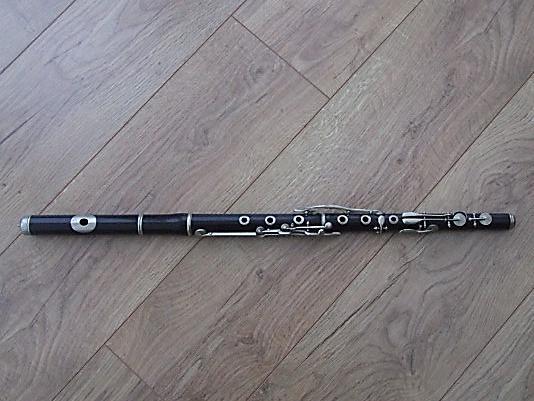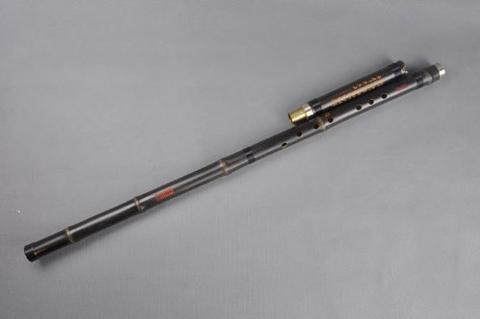The first image is the image on the left, the second image is the image on the right. For the images shown, is this caption "A flute is oriented vertically." true? Answer yes or no. No. The first image is the image on the left, the second image is the image on the right. For the images displayed, is the sentence "The instrument on the left is horizontal, the one on the right is diagonal." factually correct? Answer yes or no. Yes. 